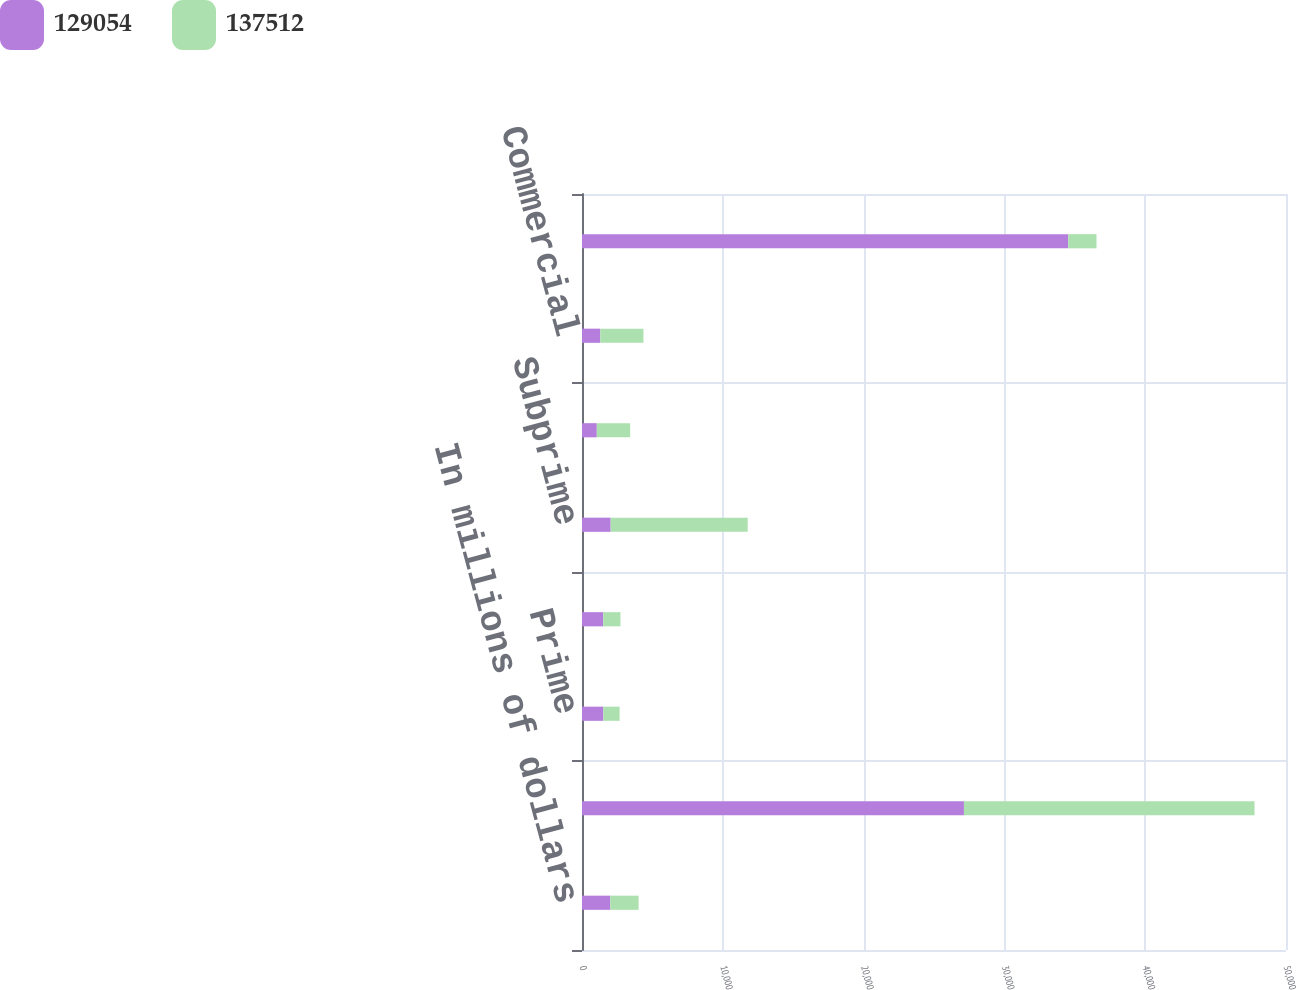<chart> <loc_0><loc_0><loc_500><loc_500><stacked_bar_chart><ecel><fcel>In millions of dollars<fcel>US government-sponsored agency<fcel>Prime<fcel>Alt-A<fcel>Subprime<fcel>Non-US residential<fcel>Commercial<fcel>Total mortgage-backed<nl><fcel>129054<fcel>2010<fcel>27127<fcel>1514<fcel>1502<fcel>2036<fcel>1052<fcel>1301<fcel>34532<nl><fcel>137512<fcel>2009<fcel>20638<fcel>1156<fcel>1229<fcel>9734<fcel>2368<fcel>3062<fcel>2010<nl></chart> 